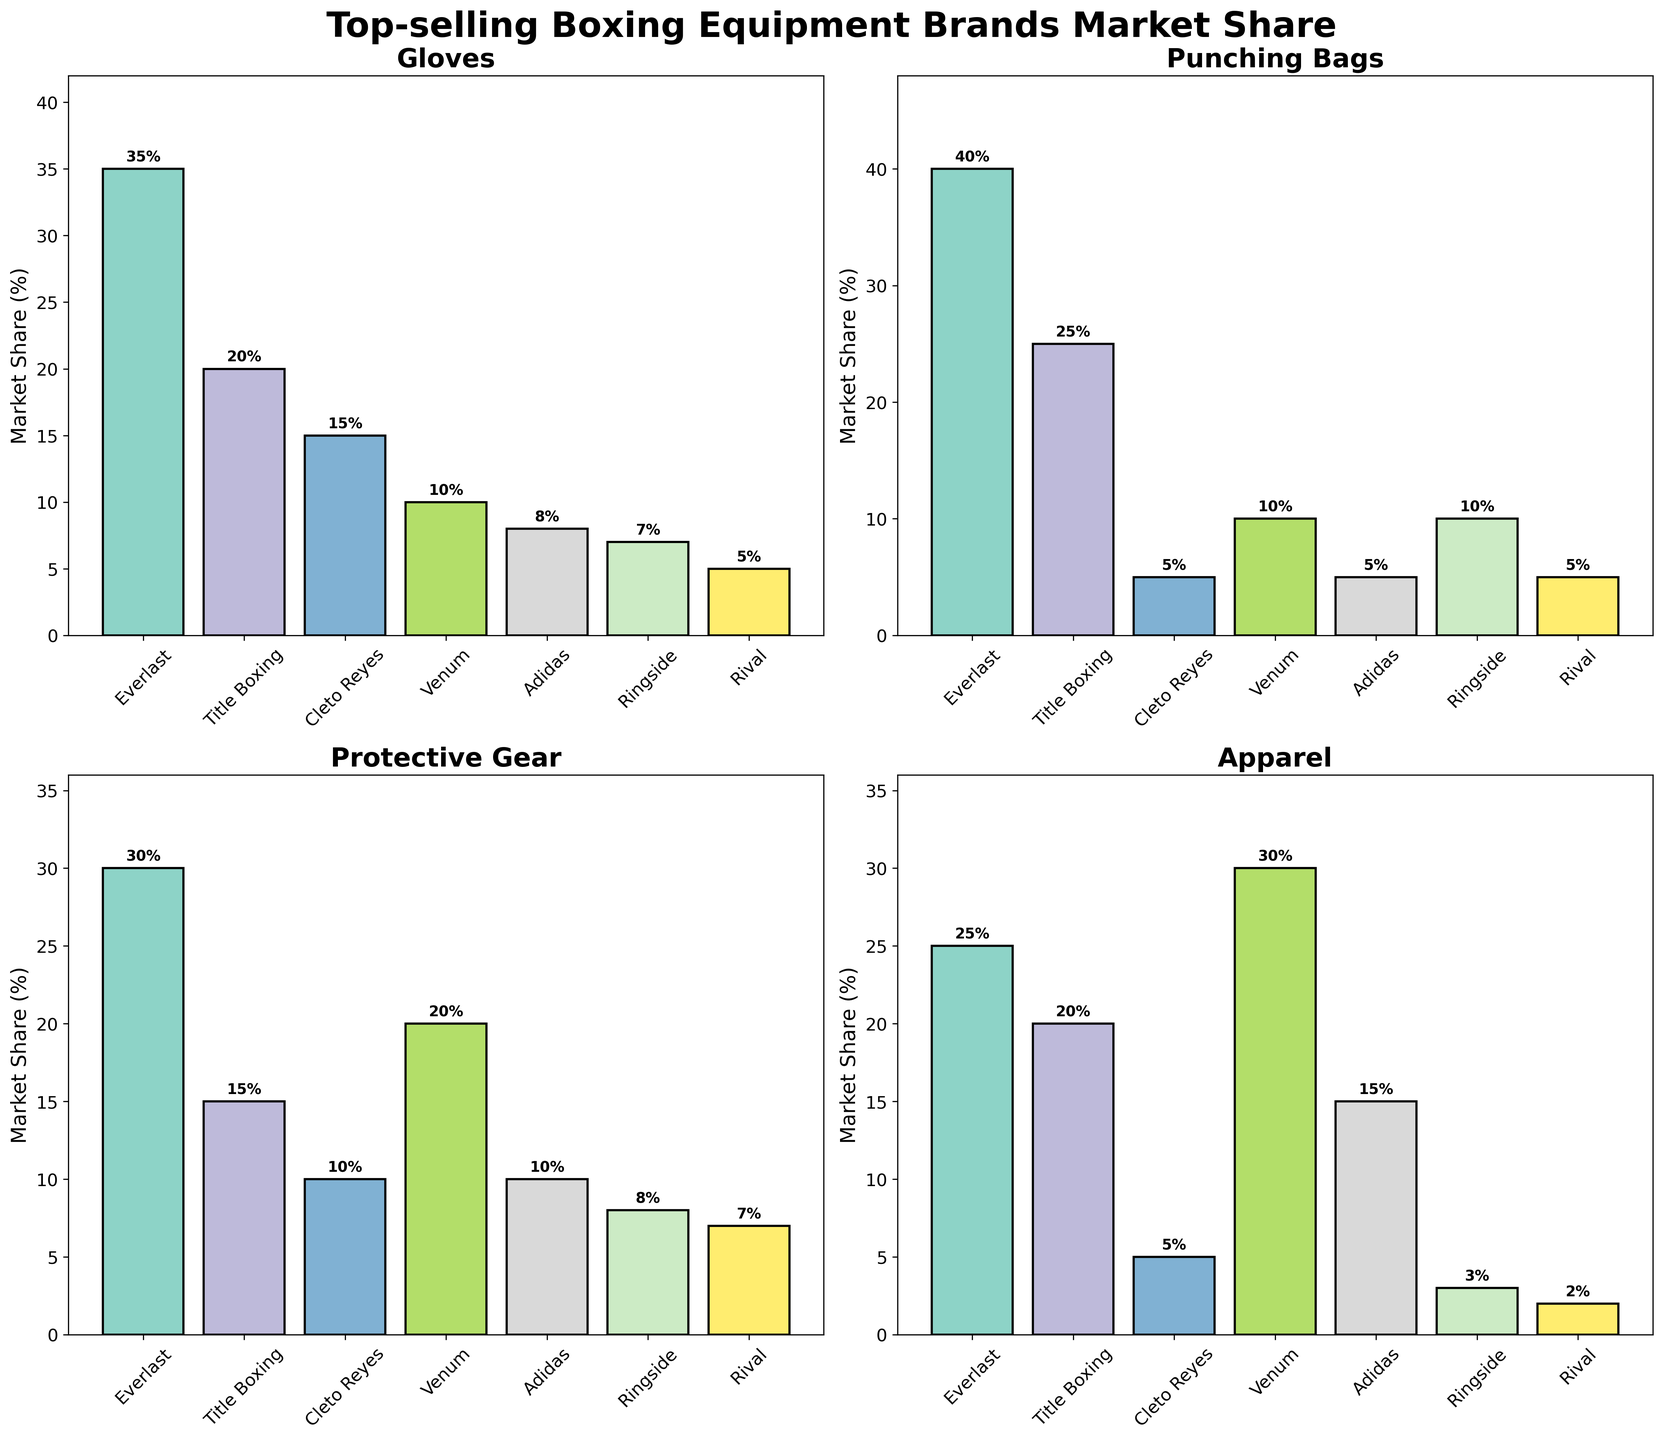What is the title of the figure? The title of the figure is prominently displayed at the top. It reads "Top-selling Boxing Equipment Brands Market Share".
Answer: Top-selling Boxing Equipment Brands Market Share Which brand has the highest market share in Gloves? By looking at the "Gloves" subplot, we see that the highest bar belongs to Everlast. The annotated value on the bar is 35%.
Answer: Everlast How many categories are represented in the plots? There are four subplots, each representing a different category. These categories are Gloves, Punching Bags, Protective Gear, and Apparel.
Answer: 4 What is the total market share of Title Boxing in all categories combined? By summing the market share percentages for Title Boxing in each category: 20 (Gloves) + 25 (Punching Bags) + 15 (Protective Gear) + 20 (Apparel), we get a total.
Answer: 80 Which category shows the highest market share for Venum? By comparing bars across all subplots, we see that the highest bar for Venum is in the Apparel category with a market share of 30%.
Answer: Apparel Compare the market share of Ringside in Punching Bags and Protective Gear. Which is higher? Looking at the bars for Ringside in the Punching Bags and Protective Gear subplots, we see values of 10% and 8%, respectively. Thus, the market share is higher in Punching Bags.
Answer: Punching Bags What is the difference between the highest and lowest market share in Protective Gear? The highest value in the Protective Gear subplot is 30% (Everlast) and the lowest is 7% (Rival). The difference is calculated as 30% - 7%.
Answer: 23 Which brand has the least market share in Apparel? By inspecting the Apparel subplot, we see that Rival has the smallest bar, with a market share of 2%.
Answer: Rival In which category does Adidas have its highest market share? By comparing the heights of Adidas bars across all subplots, we find that the highest share for Adidas is in the Apparel category, with 15%.
Answer: Apparel 